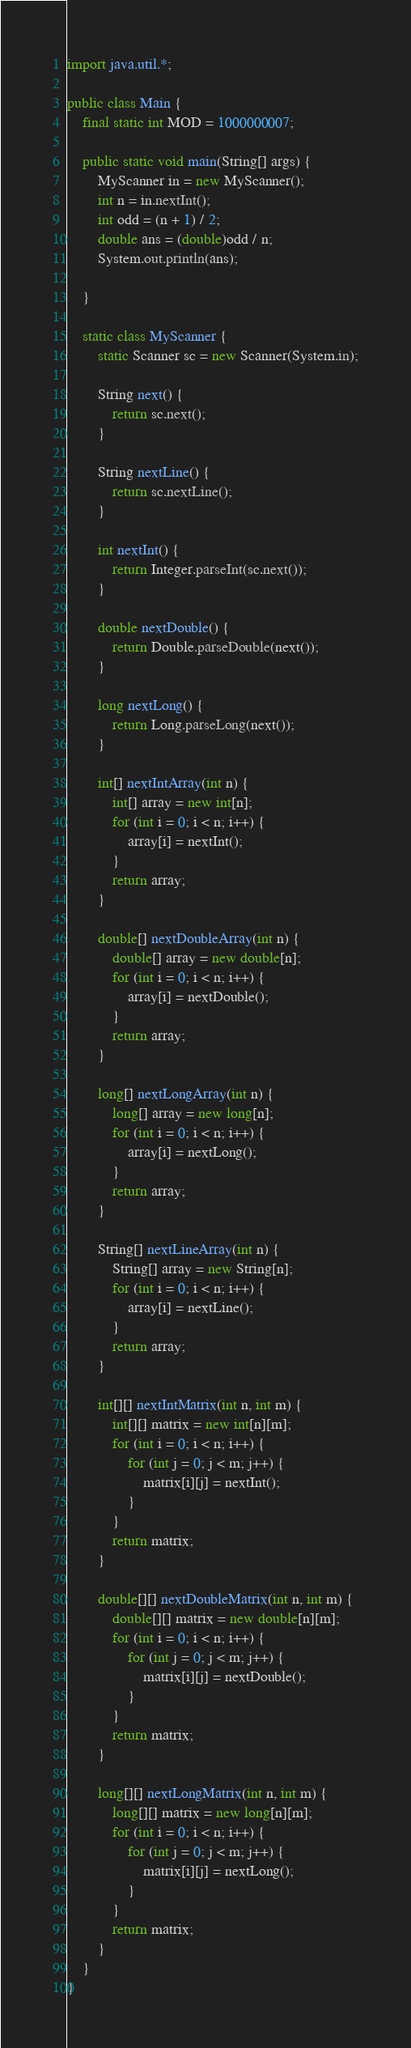<code> <loc_0><loc_0><loc_500><loc_500><_Java_>import java.util.*;

public class Main {
    final static int MOD = 1000000007;
    
    public static void main(String[] args) {
        MyScanner in = new MyScanner();
        int n = in.nextInt();
        int odd = (n + 1) / 2;
        double ans = (double)odd / n;
        System.out.println(ans);
        
    }
    
    static class MyScanner {
        static Scanner sc = new Scanner(System.in);
        
        String next() {
            return sc.next();
        }
        
        String nextLine() {
            return sc.nextLine();
        }
        
        int nextInt() {
            return Integer.parseInt(sc.next());
        }
        
        double nextDouble() {
            return Double.parseDouble(next());
        }
        
        long nextLong() {
            return Long.parseLong(next());
        }
        
        int[] nextIntArray(int n) {
            int[] array = new int[n];
            for (int i = 0; i < n; i++) {
                array[i] = nextInt();
            }
            return array;
        }
        
        double[] nextDoubleArray(int n) {
            double[] array = new double[n];
            for (int i = 0; i < n; i++) {
                array[i] = nextDouble();
            }
            return array;
        }
        
        long[] nextLongArray(int n) {
            long[] array = new long[n];
            for (int i = 0; i < n; i++) {
                array[i] = nextLong();
            }
            return array;
        }
        
        String[] nextLineArray(int n) {
            String[] array = new String[n];
            for (int i = 0; i < n; i++) {
                array[i] = nextLine();
            }
            return array;
        }
        
        int[][] nextIntMatrix(int n, int m) {
            int[][] matrix = new int[n][m];
            for (int i = 0; i < n; i++) {
                for (int j = 0; j < m; j++) {
                    matrix[i][j] = nextInt();
                }
            }
            return matrix;
        }
        
        double[][] nextDoubleMatrix(int n, int m) {
            double[][] matrix = new double[n][m];
            for (int i = 0; i < n; i++) {
                for (int j = 0; j < m; j++) {
                    matrix[i][j] = nextDouble();
                }
            }
            return matrix;
        }
        
        long[][] nextLongMatrix(int n, int m) {
            long[][] matrix = new long[n][m];
            for (int i = 0; i < n; i++) {
                for (int j = 0; j < m; j++) {
                    matrix[i][j] = nextLong();
                }
            }
            return matrix;
        }
    }
}</code> 